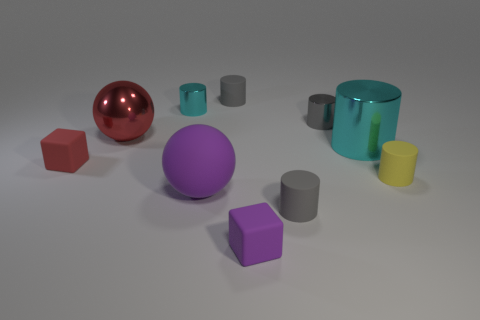How many gray cylinders must be subtracted to get 1 gray cylinders? 2 Subtract all cyan spheres. How many gray cylinders are left? 3 Subtract 1 cylinders. How many cylinders are left? 5 Subtract all yellow cylinders. How many cylinders are left? 5 Subtract all big cyan metal cylinders. How many cylinders are left? 5 Subtract all brown cylinders. Subtract all gray spheres. How many cylinders are left? 6 Subtract all balls. How many objects are left? 8 Subtract all small shiny things. Subtract all yellow cylinders. How many objects are left? 7 Add 2 red metal things. How many red metal things are left? 3 Add 7 large blue rubber cylinders. How many large blue rubber cylinders exist? 7 